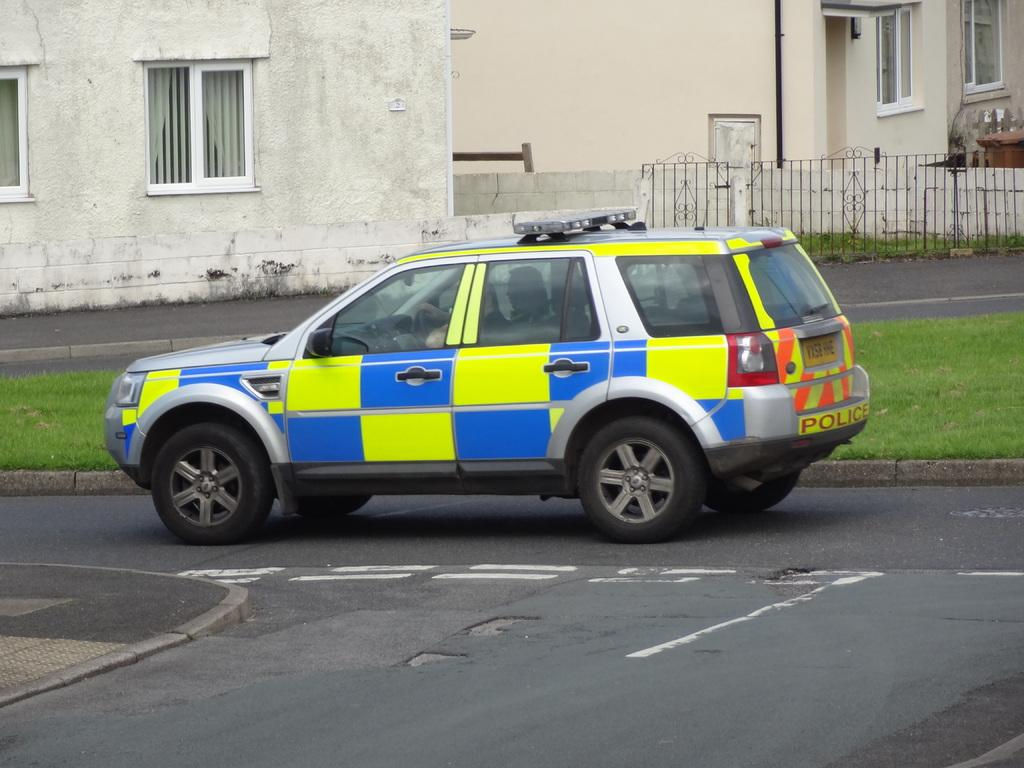What is the main subject of the image? There is a car on the road in the image. What can be seen in the background of the image? There is grass, houses, and a fence visible in the background of the image. What type of lipstick is the car wearing in the image? Cars do not wear lipstick, as they are inanimate objects. The image features a car on the road, and there is no mention of lipstick or any cosmetic products. 